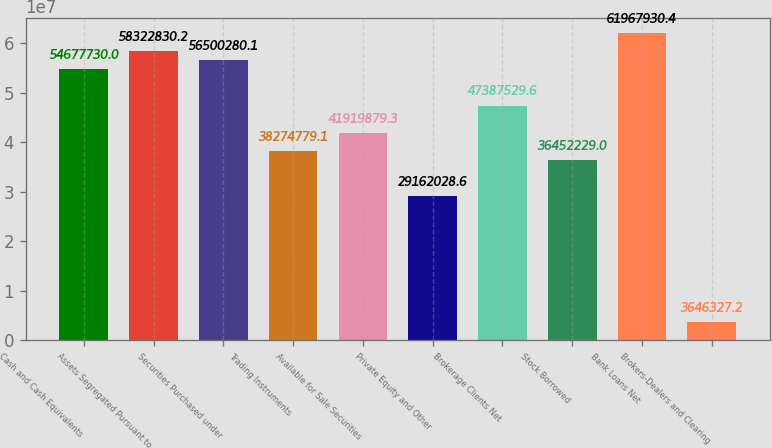Convert chart to OTSL. <chart><loc_0><loc_0><loc_500><loc_500><bar_chart><fcel>Cash and Cash Equivalents<fcel>Assets Segregated Pursuant to<fcel>Securities Purchased under<fcel>Trading Instruments<fcel>Available for Sale Securities<fcel>Private Equity and Other<fcel>Brokerage Clients Net<fcel>Stock Borrowed<fcel>Bank Loans Net<fcel>Brokers-Dealers and Clearing<nl><fcel>5.46777e+07<fcel>5.83228e+07<fcel>5.65003e+07<fcel>3.82748e+07<fcel>4.19199e+07<fcel>2.9162e+07<fcel>4.73875e+07<fcel>3.64522e+07<fcel>6.19679e+07<fcel>3.64633e+06<nl></chart> 